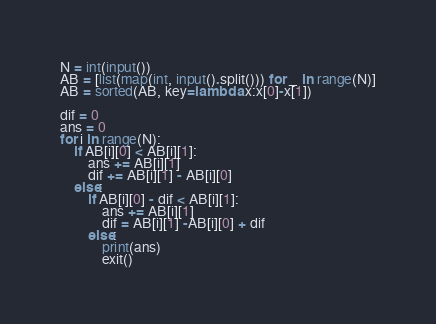<code> <loc_0><loc_0><loc_500><loc_500><_Python_>N = int(input())
AB = [list(map(int, input().split())) for _ in range(N)]
AB = sorted(AB, key=lambda x:x[0]-x[1])

dif = 0
ans = 0
for i in range(N):
    if AB[i][0] < AB[i][1]:
        ans += AB[i][1]
        dif += AB[i][1] - AB[i][0]
    else:
        if AB[i][0] - dif < AB[i][1]:
            ans += AB[i][1]
            dif = AB[i][1] -AB[i][0] + dif
        else:
            print(ans)
            exit()
</code> 